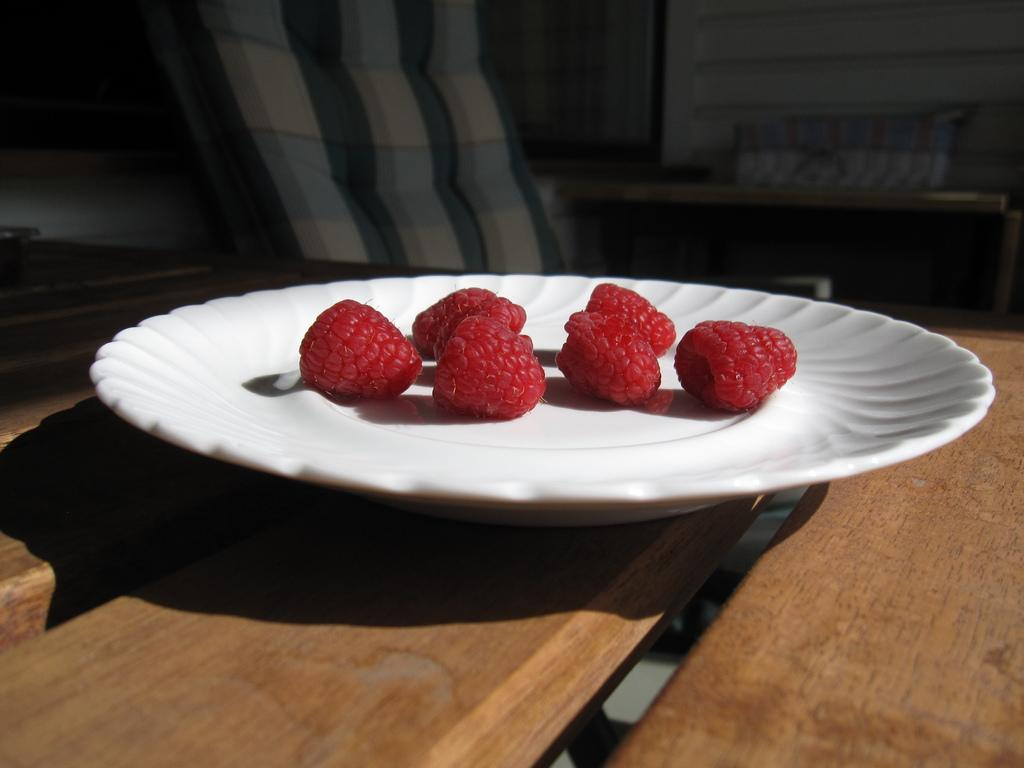What type of furniture is present in the image? There is a table and a chair in the image. What is the background of the image? There is a wall in the image. What is on the table in the image? There is a plate on the table. What is on the plate? The plate contains strawberries. Is there a lumberjack sitting on the chair in the image? There is no lumberjack or any indication of a lumberjack in the image. 